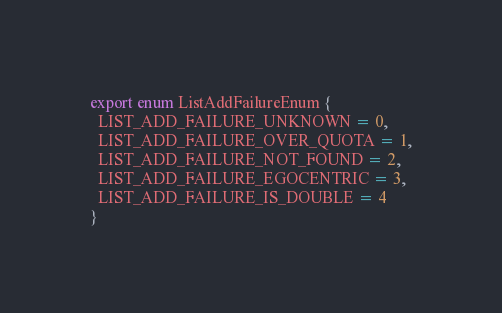Convert code to text. <code><loc_0><loc_0><loc_500><loc_500><_TypeScript_>export enum ListAddFailureEnum {
  LIST_ADD_FAILURE_UNKNOWN = 0,
  LIST_ADD_FAILURE_OVER_QUOTA = 1,
  LIST_ADD_FAILURE_NOT_FOUND = 2,
  LIST_ADD_FAILURE_EGOCENTRIC = 3,
  LIST_ADD_FAILURE_IS_DOUBLE = 4
}
</code> 